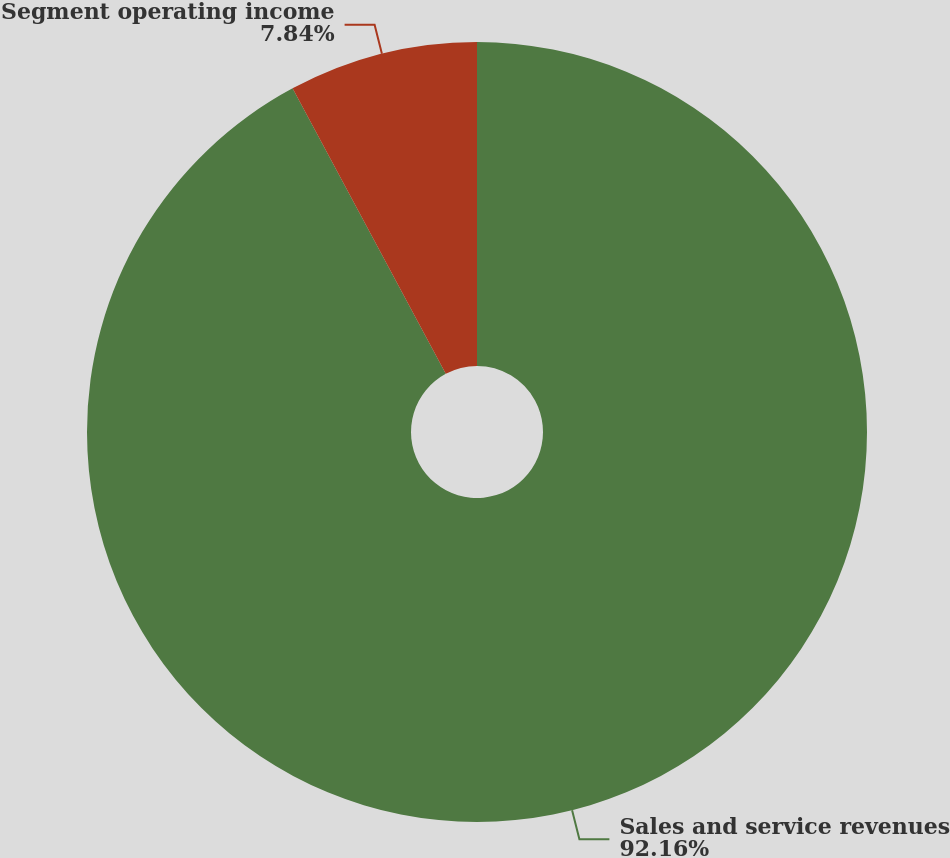Convert chart to OTSL. <chart><loc_0><loc_0><loc_500><loc_500><pie_chart><fcel>Sales and service revenues<fcel>Segment operating income<nl><fcel>92.16%<fcel>7.84%<nl></chart> 